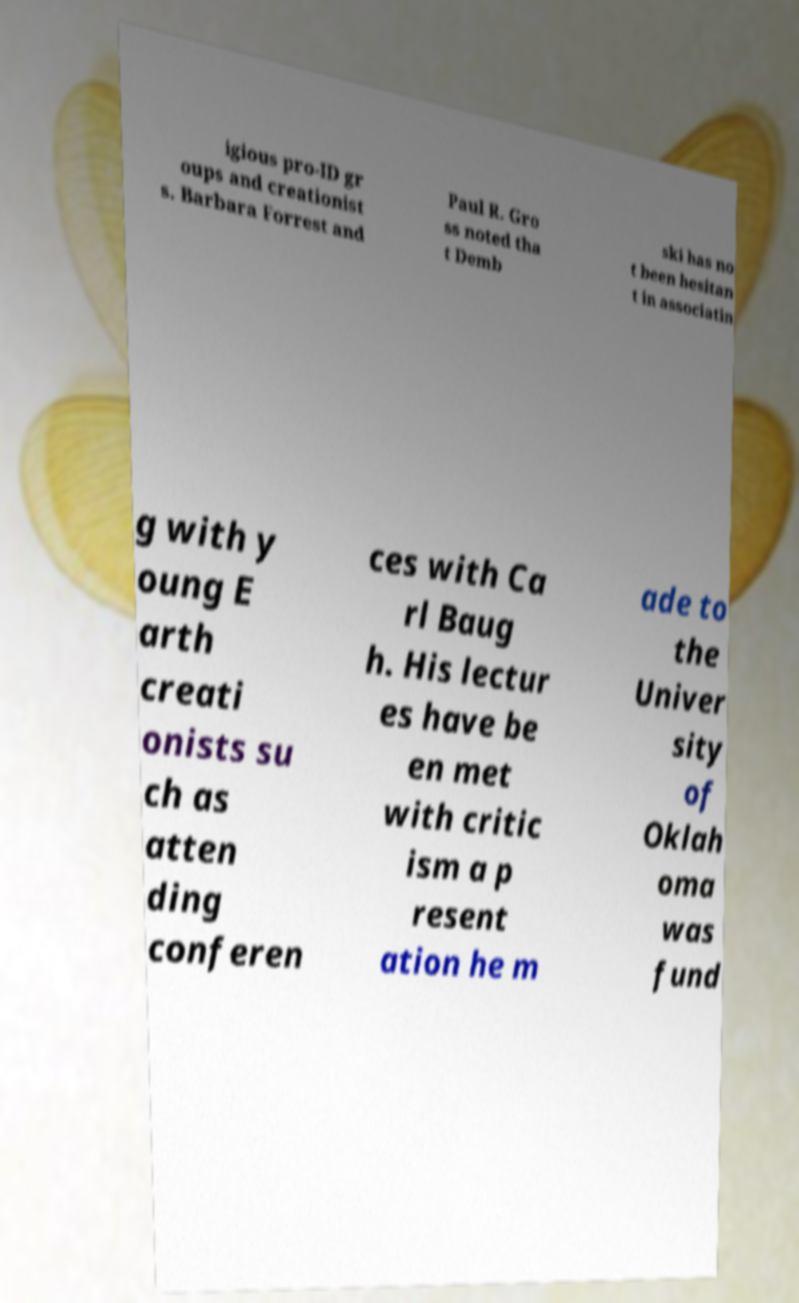Could you assist in decoding the text presented in this image and type it out clearly? igious pro-ID gr oups and creationist s. Barbara Forrest and Paul R. Gro ss noted tha t Demb ski has no t been hesitan t in associatin g with y oung E arth creati onists su ch as atten ding conferen ces with Ca rl Baug h. His lectur es have be en met with critic ism a p resent ation he m ade to the Univer sity of Oklah oma was fund 